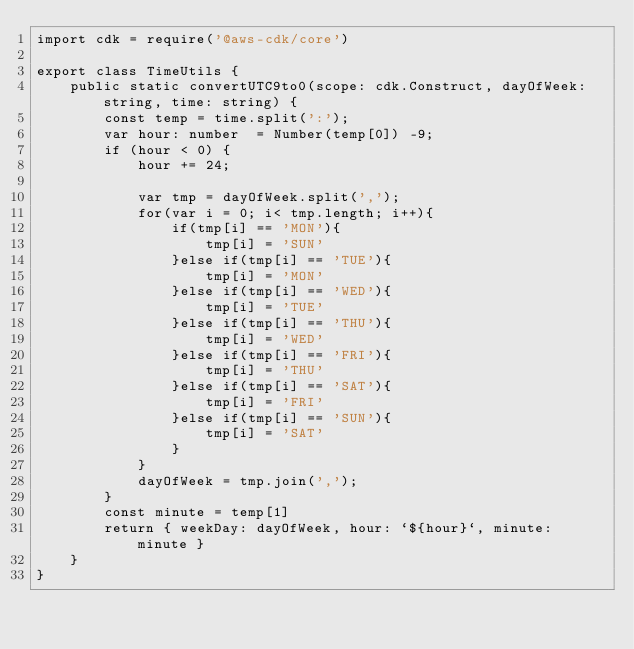Convert code to text. <code><loc_0><loc_0><loc_500><loc_500><_TypeScript_>import cdk = require('@aws-cdk/core')

export class TimeUtils {
    public static convertUTC9to0(scope: cdk.Construct, dayOfWeek: string, time: string) {
        const temp = time.split(':');
        var hour: number  = Number(temp[0]) -9;
        if (hour < 0) { 
            hour += 24;

            var tmp = dayOfWeek.split(',');
            for(var i = 0; i< tmp.length; i++){
                if(tmp[i] == 'MON'){
                    tmp[i] = 'SUN'
                }else if(tmp[i] == 'TUE'){
                    tmp[i] = 'MON'
                }else if(tmp[i] == 'WED'){
                    tmp[i] = 'TUE'
                }else if(tmp[i] == 'THU'){
                    tmp[i] = 'WED'
                }else if(tmp[i] == 'FRI'){
                    tmp[i] = 'THU'
                }else if(tmp[i] == 'SAT'){
                    tmp[i] = 'FRI'
                }else if(tmp[i] == 'SUN'){
                    tmp[i] = 'SAT'
                }
            }
            dayOfWeek = tmp.join(',');
        }
        const minute = temp[1]
        return { weekDay: dayOfWeek, hour: `${hour}`, minute: minute }
    }
}</code> 